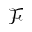<formula> <loc_0><loc_0><loc_500><loc_500>\mathcal { F }</formula> 